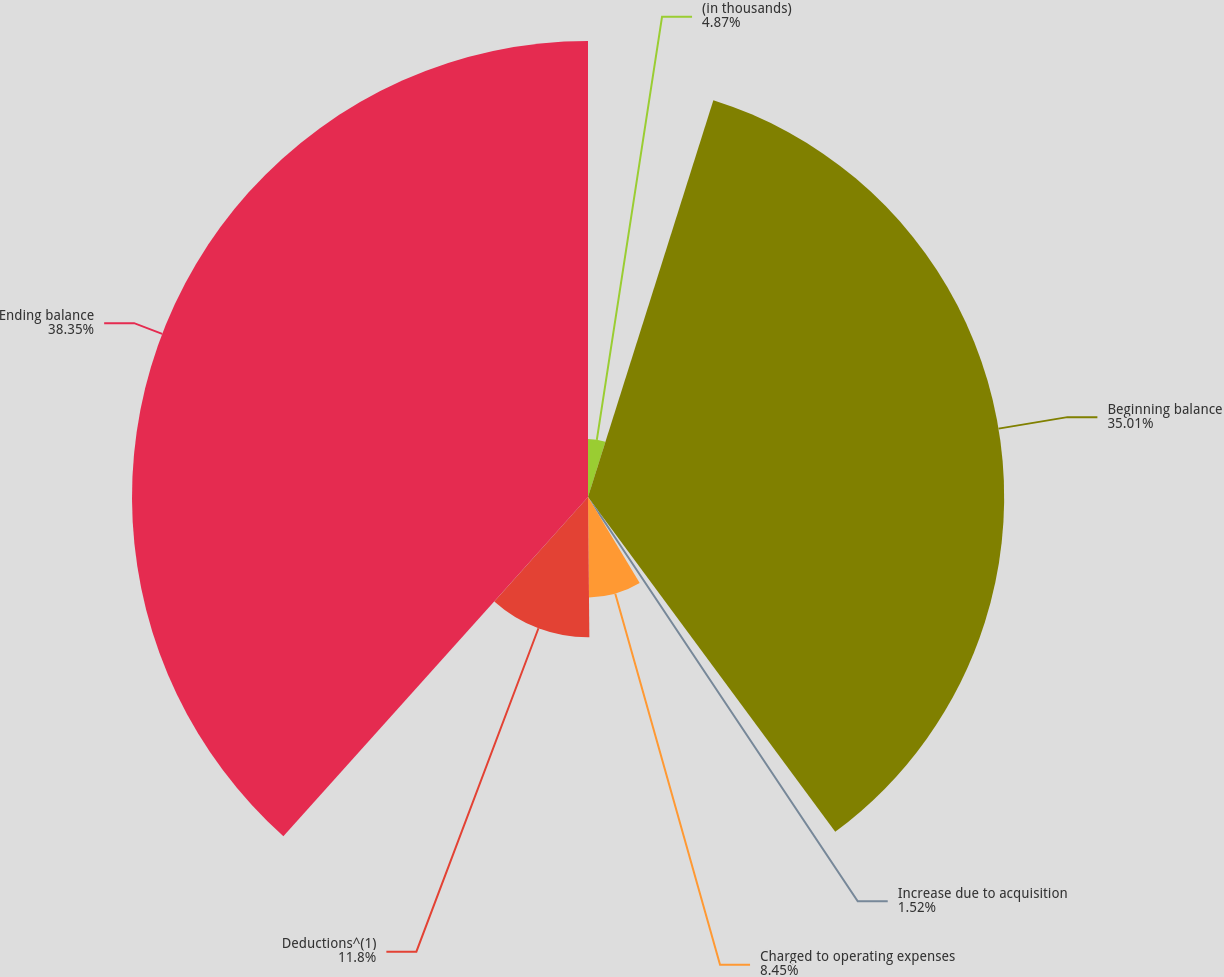Convert chart to OTSL. <chart><loc_0><loc_0><loc_500><loc_500><pie_chart><fcel>(in thousands)<fcel>Beginning balance<fcel>Increase due to acquisition<fcel>Charged to operating expenses<fcel>Deductions^(1)<fcel>Ending balance<nl><fcel>4.87%<fcel>35.01%<fcel>1.52%<fcel>8.45%<fcel>11.8%<fcel>38.36%<nl></chart> 